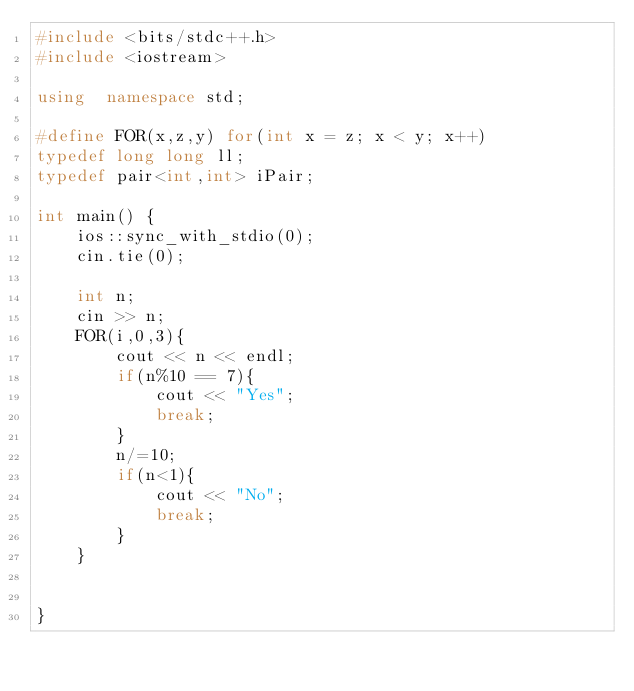Convert code to text. <code><loc_0><loc_0><loc_500><loc_500><_C++_>#include <bits/stdc++.h>
#include <iostream>

using  namespace std;

#define FOR(x,z,y) for(int x = z; x < y; x++)
typedef long long ll;
typedef pair<int,int> iPair;

int main() {
    ios::sync_with_stdio(0);
    cin.tie(0);

    int n;
    cin >> n;
    FOR(i,0,3){
        cout << n << endl;
        if(n%10 == 7){
            cout << "Yes";
            break;
        }
        n/=10;
        if(n<1){
            cout << "No";
            break;
        }
    }


}
</code> 